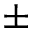<formula> <loc_0><loc_0><loc_500><loc_500>\pm</formula> 